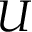<formula> <loc_0><loc_0><loc_500><loc_500>U</formula> 